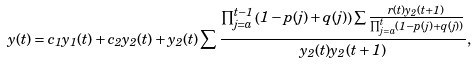Convert formula to latex. <formula><loc_0><loc_0><loc_500><loc_500>y ( t ) = c _ { 1 } y _ { 1 } ( t ) + c _ { 2 } y _ { 2 } ( t ) + y _ { 2 } ( t ) \sum \frac { \prod _ { j = a } ^ { t - 1 } \left ( 1 - p ( j ) + q ( j ) \right ) \sum \frac { r ( t ) y _ { 2 } ( t + 1 ) } { \prod _ { j = a } ^ { t } \left ( 1 - p ( j ) + q ( j ) \right ) } } { y _ { 2 } ( t ) y _ { 2 } ( t + 1 ) } ,</formula> 